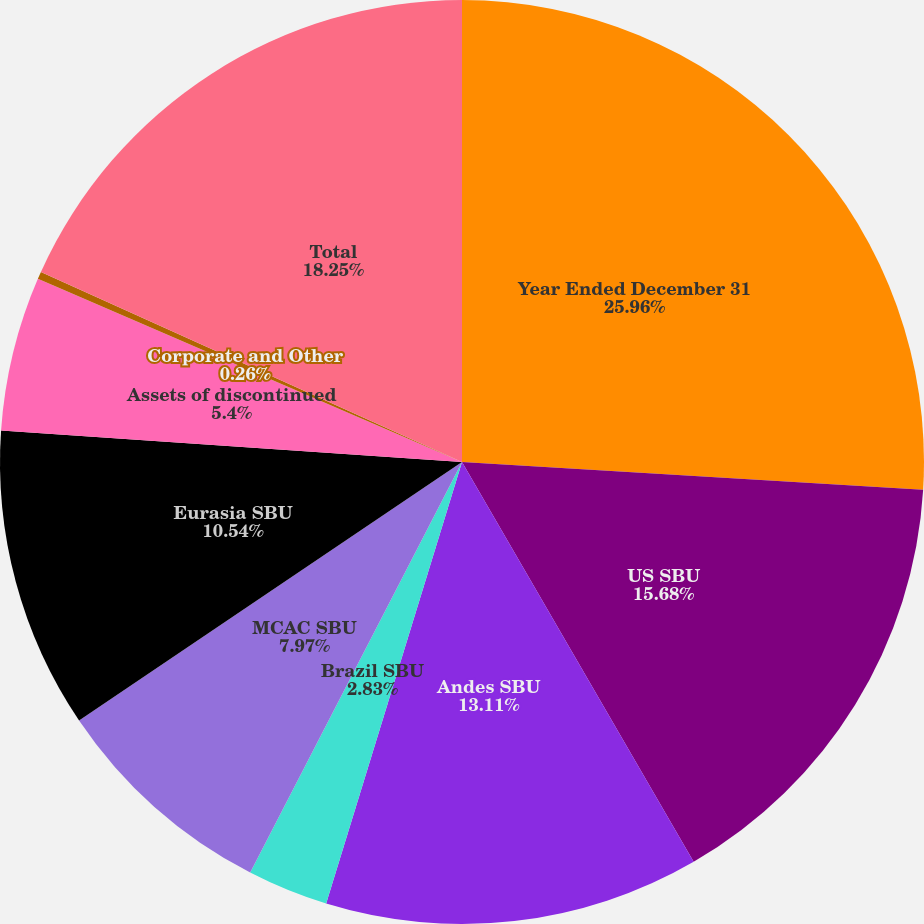<chart> <loc_0><loc_0><loc_500><loc_500><pie_chart><fcel>Year Ended December 31<fcel>US SBU<fcel>Andes SBU<fcel>Brazil SBU<fcel>MCAC SBU<fcel>Eurasia SBU<fcel>Assets of discontinued<fcel>Corporate and Other<fcel>Total<nl><fcel>25.96%<fcel>15.68%<fcel>13.11%<fcel>2.83%<fcel>7.97%<fcel>10.54%<fcel>5.4%<fcel>0.26%<fcel>18.25%<nl></chart> 